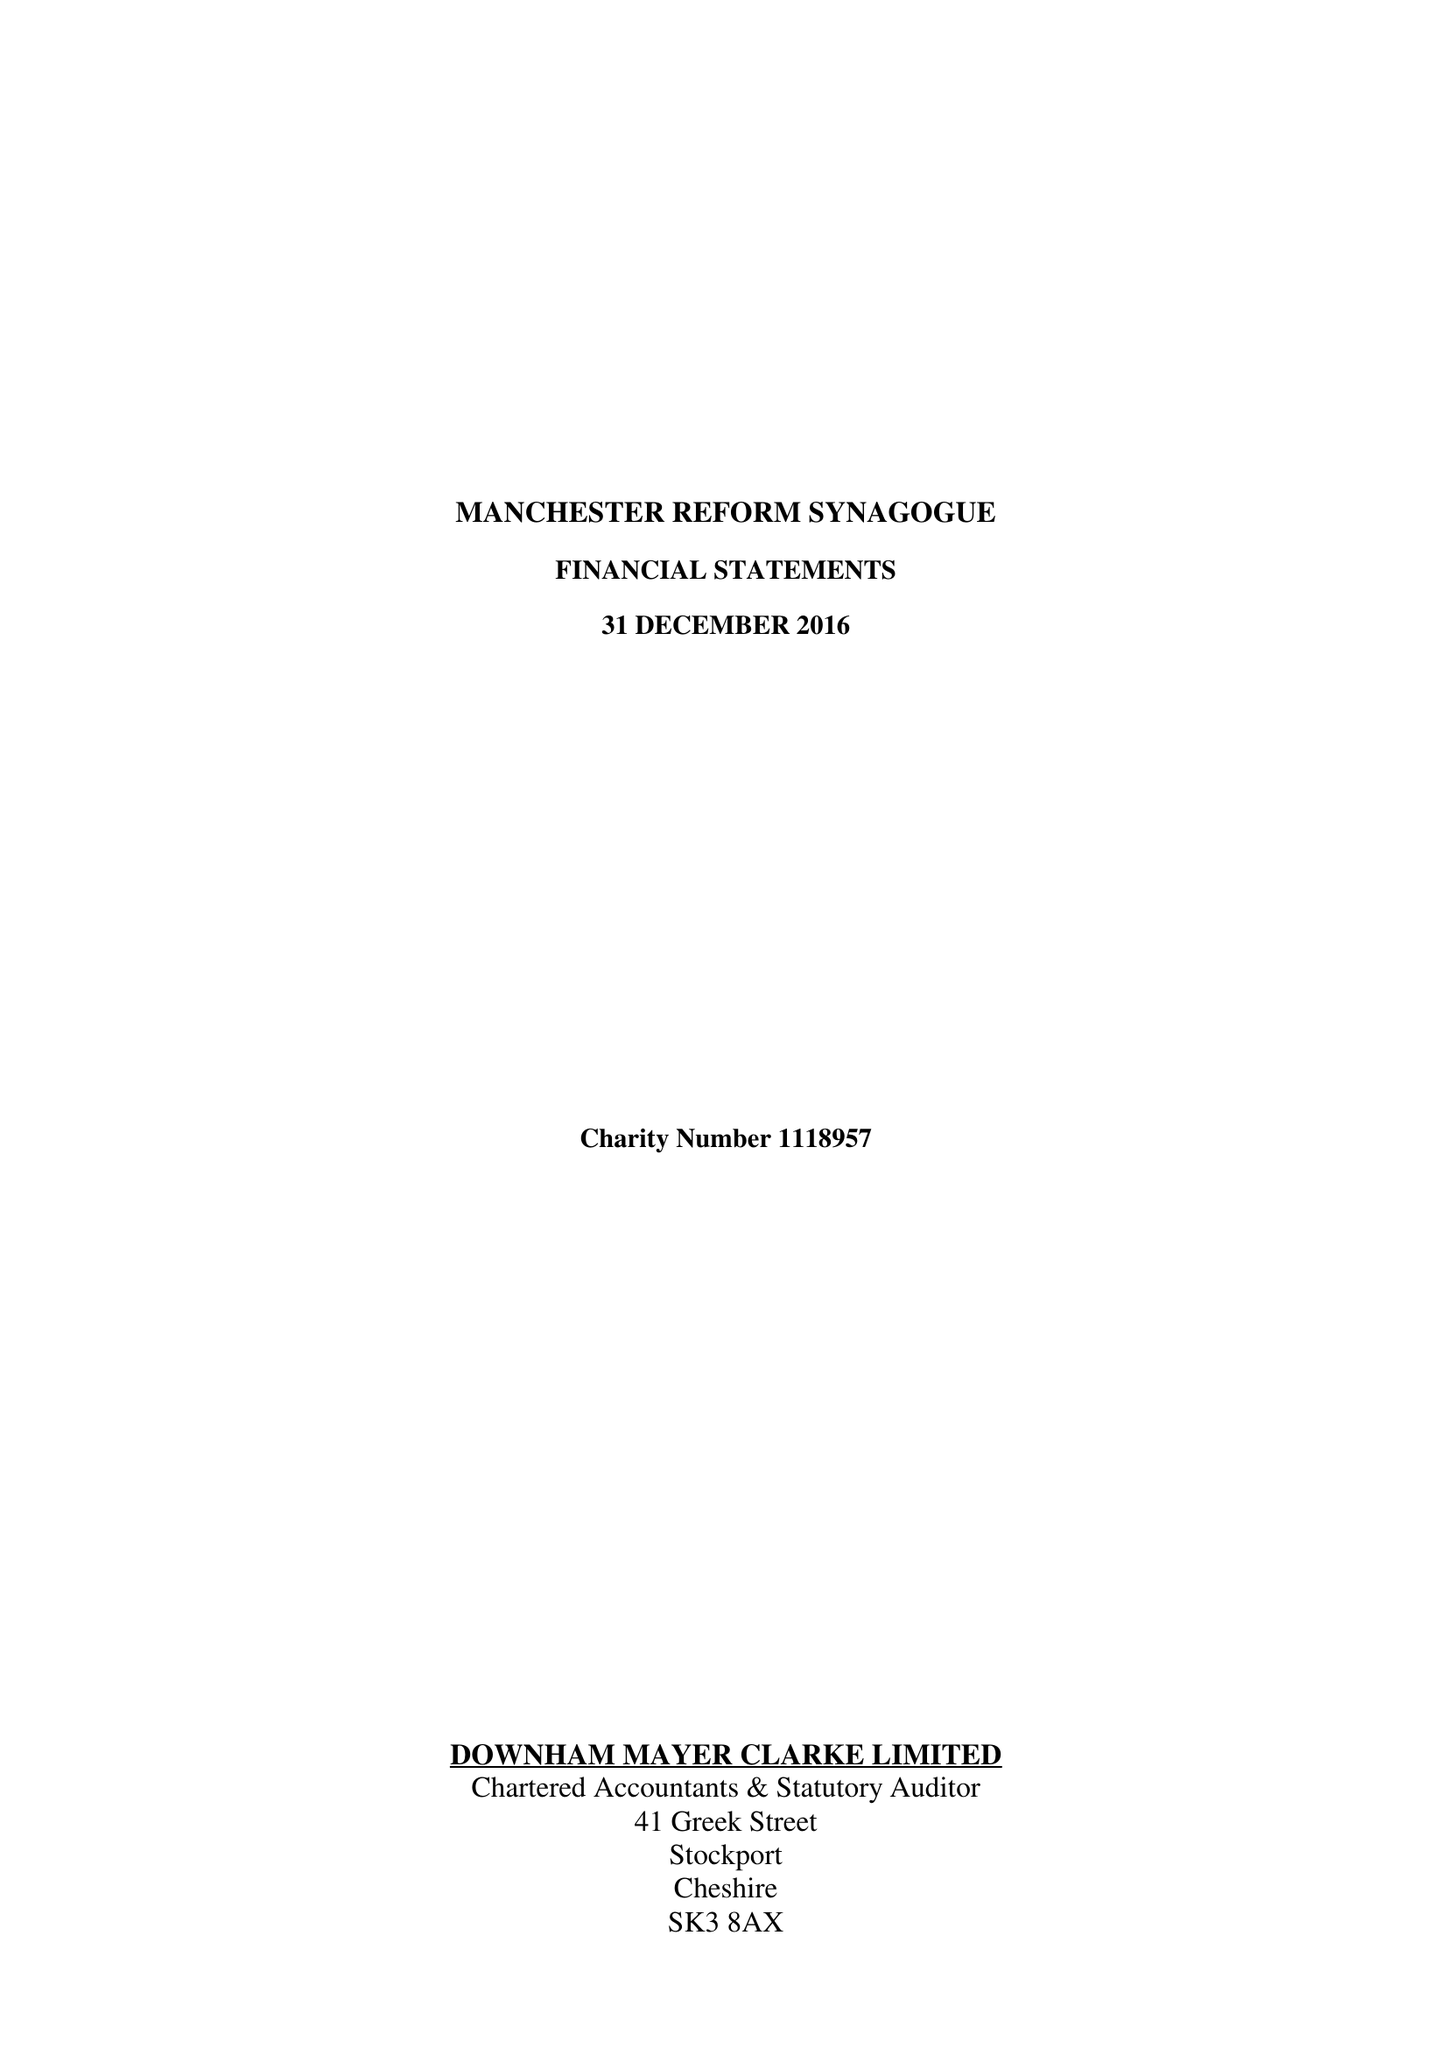What is the value for the charity_name?
Answer the question using a single word or phrase. Manchester Reform Congregation 